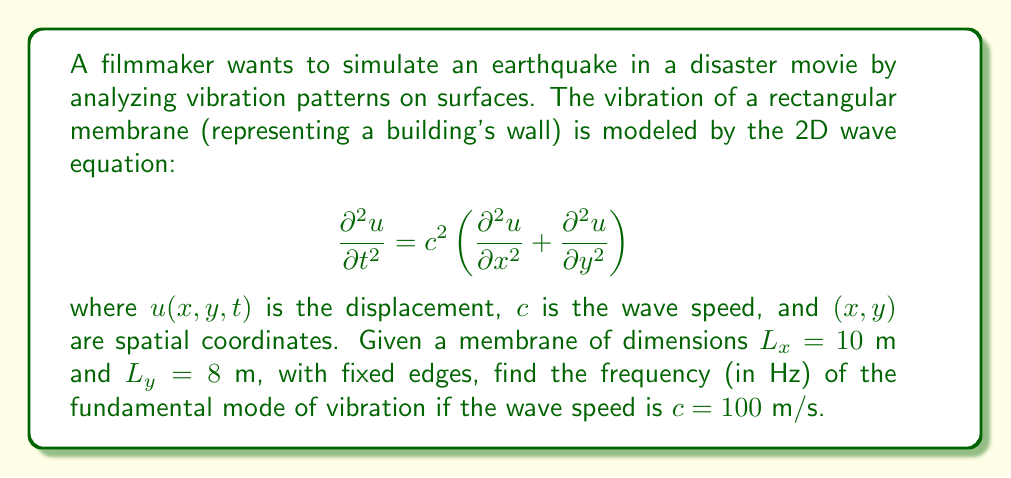Could you help me with this problem? To solve this problem, we'll follow these steps:

1) For a rectangular membrane with fixed edges, the general solution for the wave equation is:

   $$u(x,y,t) = \sum_{m=1}^{\infty}\sum_{n=1}^{\infty} A_{mn} \sin\left(\frac{m\pi x}{L_x}\right)\sin\left(\frac{n\pi y}{L_y}\right)\cos(\omega_{mn}t + \phi_{mn})$$

2) The angular frequency $\omega_{mn}$ for each mode is given by:

   $$\omega_{mn} = \pi c \sqrt{\left(\frac{m}{L_x}\right)^2 + \left(\frac{n}{L_y}\right)^2}$$

3) The fundamental mode corresponds to $m=1$ and $n=1$. So we need to calculate $\omega_{11}$:

   $$\omega_{11} = \pi c \sqrt{\left(\frac{1}{L_x}\right)^2 + \left(\frac{1}{L_y}\right)^2}$$

4) Substituting the given values:

   $$\omega_{11} = \pi \cdot 100 \sqrt{\left(\frac{1}{10}\right)^2 + \left(\frac{1}{8}\right)^2}$$

5) Simplify:

   $$\omega_{11} = 100\pi \sqrt{\frac{1}{100} + \frac{1}{64}} = 100\pi \sqrt{\frac{41}{3200}} \approx 35.61 \text{ rad/s}$$

6) Convert angular frequency to frequency in Hz:

   $$f = \frac{\omega}{2\pi} = \frac{35.61}{2\pi} \approx 5.67 \text{ Hz}$$

Thus, the frequency of the fundamental mode is approximately 5.67 Hz.
Answer: 5.67 Hz 